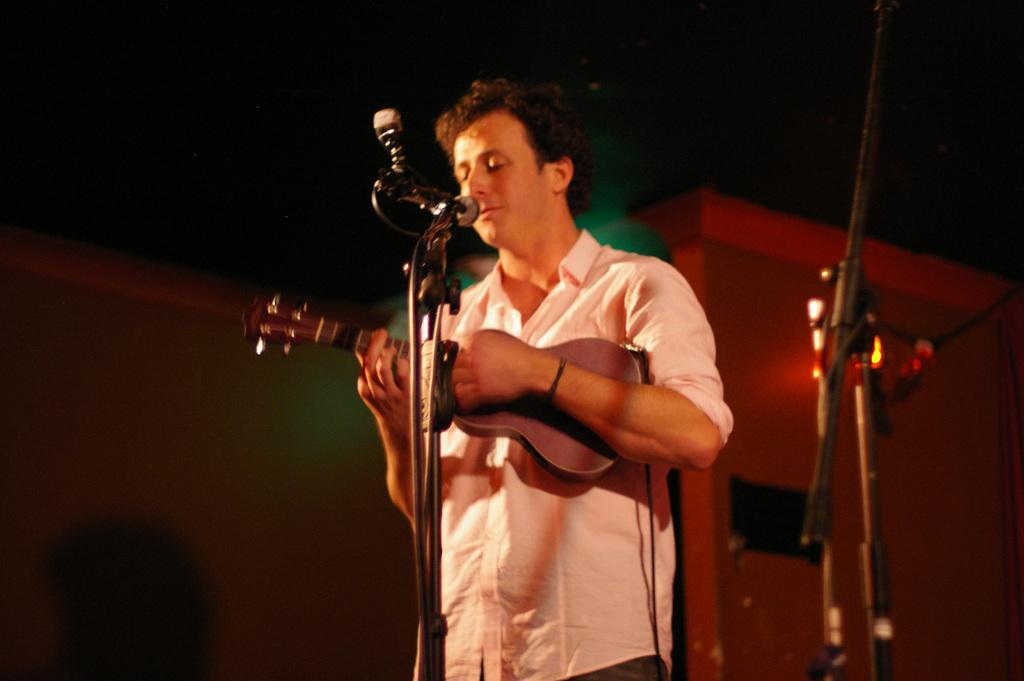What is the man in the image doing? The man is playing a guitar and singing. How is the man amplifying his voice in the image? The man is using a microphone. How many eggs are visible in the image? There are no eggs present in the image. 